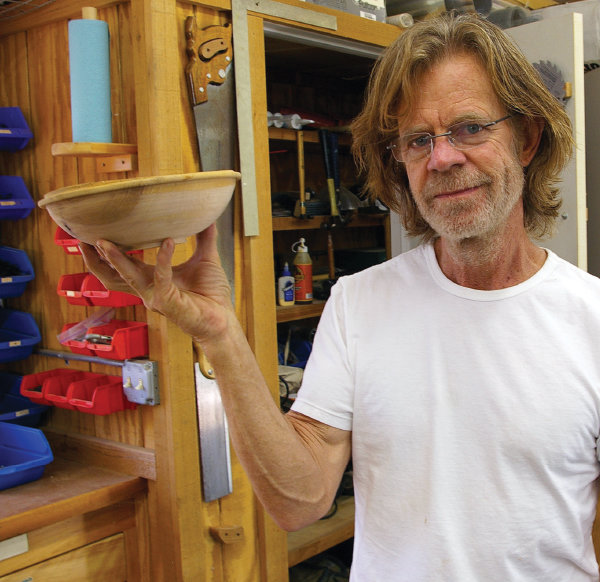Analyze the image in a comprehensive and detailed manner. The image presents a middle-aged man in a woodshop, holding a handcrafted wooden bowl. He appears adept at woodworking, evident from his relaxed posture and confident smile. The attire is simple—a white t-shirt and clear glasses—suggesting a casual setting in his personal workspace. The background is cluttered with various woodworking tools and shelves stocked with supplies, indicating a well-used and functional craft space. His engagement with the camera, combined with the natural lighting and organized environment, highlights both his skill and passion for woodworking. This scene effectively captures a personal aspect of his life, contrasting with his public persona. 